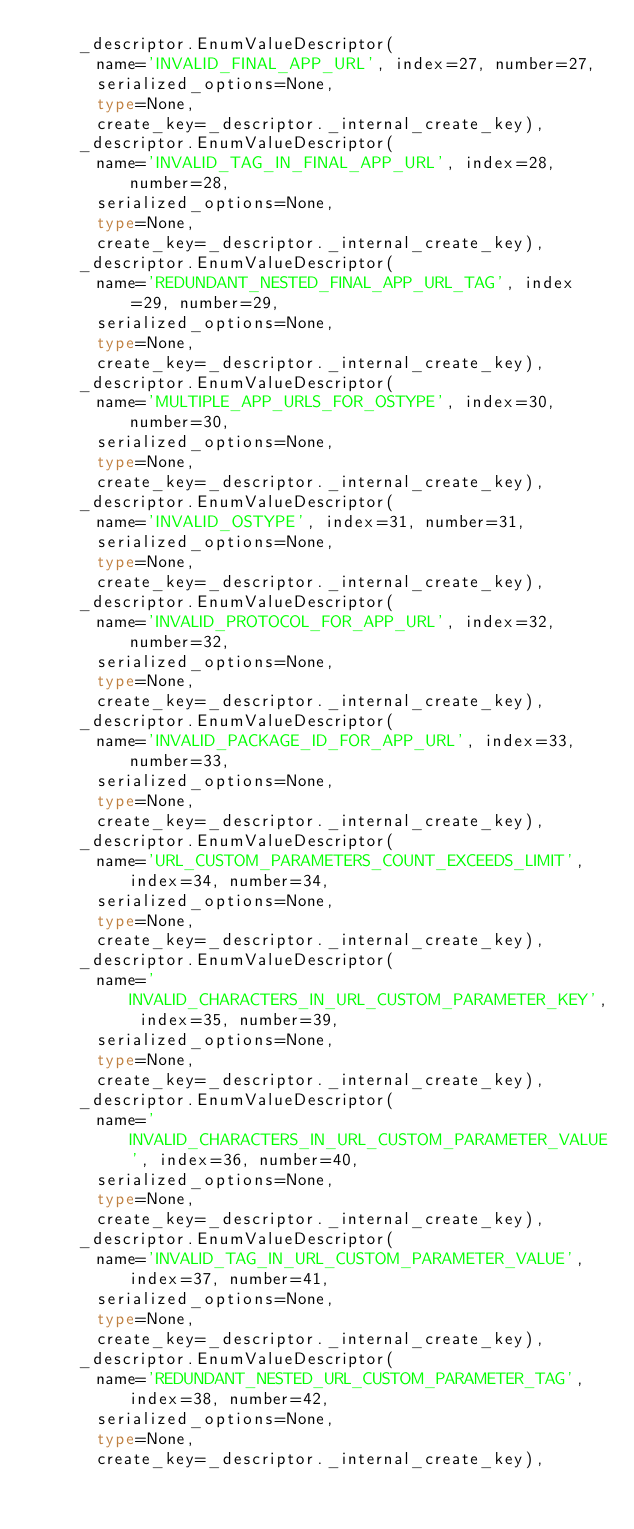Convert code to text. <code><loc_0><loc_0><loc_500><loc_500><_Python_>    _descriptor.EnumValueDescriptor(
      name='INVALID_FINAL_APP_URL', index=27, number=27,
      serialized_options=None,
      type=None,
      create_key=_descriptor._internal_create_key),
    _descriptor.EnumValueDescriptor(
      name='INVALID_TAG_IN_FINAL_APP_URL', index=28, number=28,
      serialized_options=None,
      type=None,
      create_key=_descriptor._internal_create_key),
    _descriptor.EnumValueDescriptor(
      name='REDUNDANT_NESTED_FINAL_APP_URL_TAG', index=29, number=29,
      serialized_options=None,
      type=None,
      create_key=_descriptor._internal_create_key),
    _descriptor.EnumValueDescriptor(
      name='MULTIPLE_APP_URLS_FOR_OSTYPE', index=30, number=30,
      serialized_options=None,
      type=None,
      create_key=_descriptor._internal_create_key),
    _descriptor.EnumValueDescriptor(
      name='INVALID_OSTYPE', index=31, number=31,
      serialized_options=None,
      type=None,
      create_key=_descriptor._internal_create_key),
    _descriptor.EnumValueDescriptor(
      name='INVALID_PROTOCOL_FOR_APP_URL', index=32, number=32,
      serialized_options=None,
      type=None,
      create_key=_descriptor._internal_create_key),
    _descriptor.EnumValueDescriptor(
      name='INVALID_PACKAGE_ID_FOR_APP_URL', index=33, number=33,
      serialized_options=None,
      type=None,
      create_key=_descriptor._internal_create_key),
    _descriptor.EnumValueDescriptor(
      name='URL_CUSTOM_PARAMETERS_COUNT_EXCEEDS_LIMIT', index=34, number=34,
      serialized_options=None,
      type=None,
      create_key=_descriptor._internal_create_key),
    _descriptor.EnumValueDescriptor(
      name='INVALID_CHARACTERS_IN_URL_CUSTOM_PARAMETER_KEY', index=35, number=39,
      serialized_options=None,
      type=None,
      create_key=_descriptor._internal_create_key),
    _descriptor.EnumValueDescriptor(
      name='INVALID_CHARACTERS_IN_URL_CUSTOM_PARAMETER_VALUE', index=36, number=40,
      serialized_options=None,
      type=None,
      create_key=_descriptor._internal_create_key),
    _descriptor.EnumValueDescriptor(
      name='INVALID_TAG_IN_URL_CUSTOM_PARAMETER_VALUE', index=37, number=41,
      serialized_options=None,
      type=None,
      create_key=_descriptor._internal_create_key),
    _descriptor.EnumValueDescriptor(
      name='REDUNDANT_NESTED_URL_CUSTOM_PARAMETER_TAG', index=38, number=42,
      serialized_options=None,
      type=None,
      create_key=_descriptor._internal_create_key),</code> 